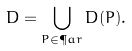Convert formula to latex. <formula><loc_0><loc_0><loc_500><loc_500>D = \bigcup _ { P \in \P a r } D ( P ) .</formula> 